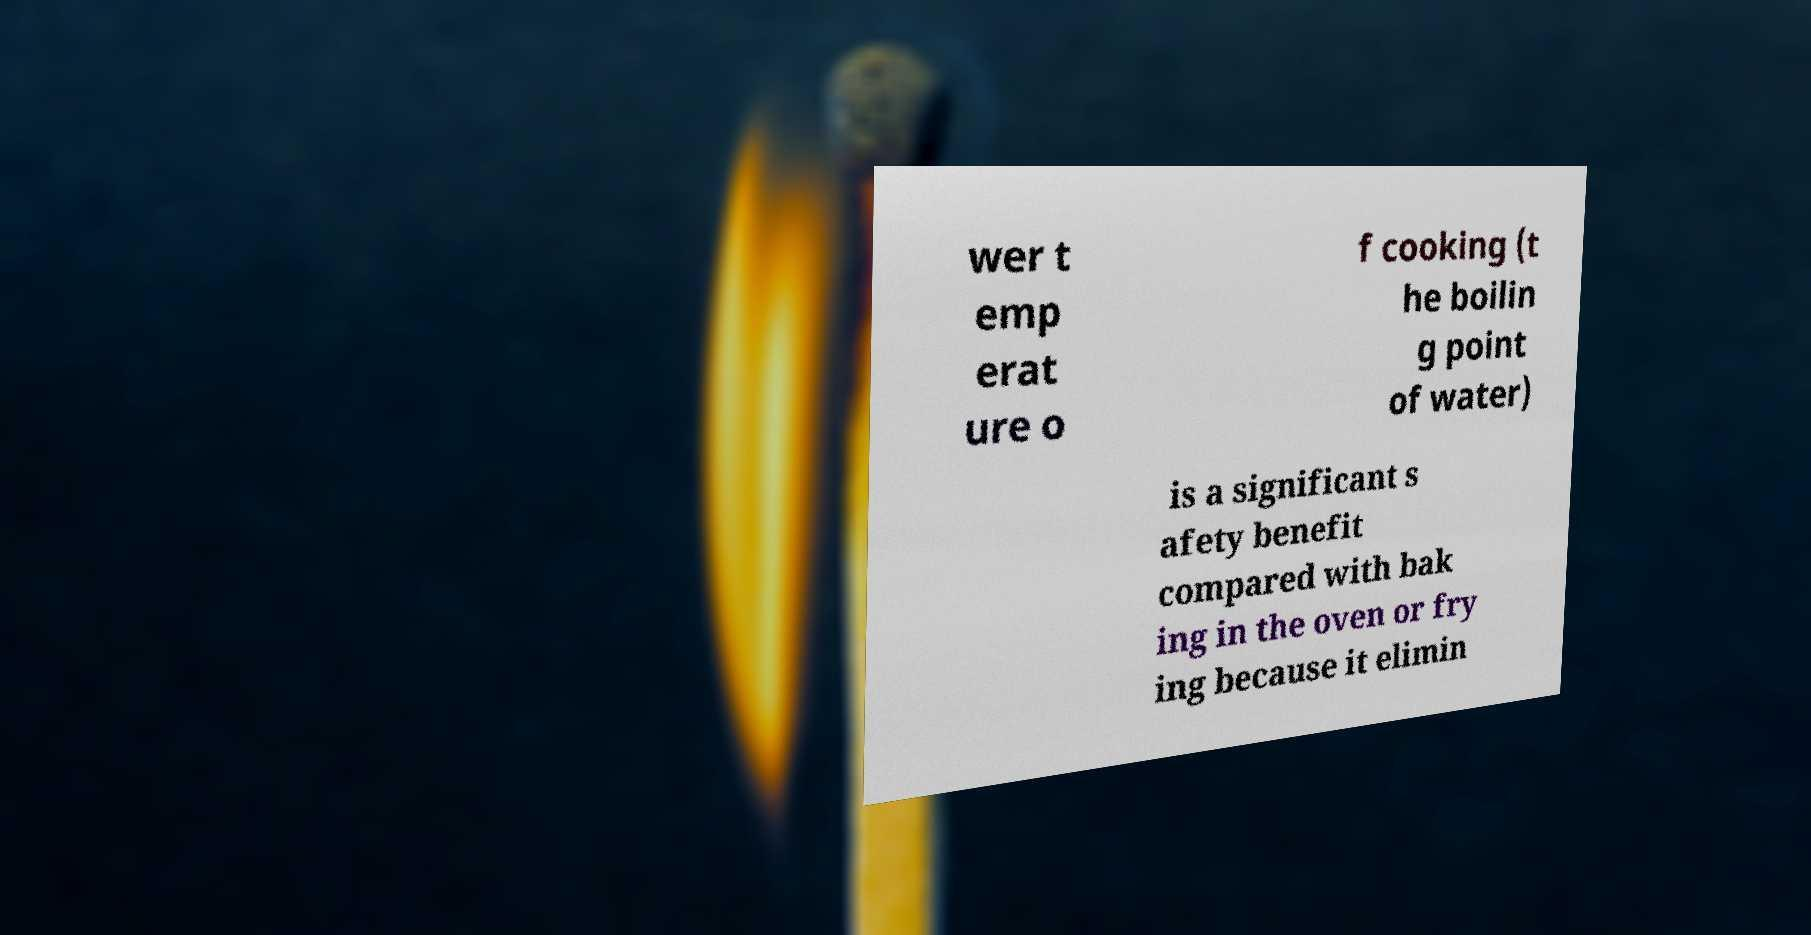I need the written content from this picture converted into text. Can you do that? wer t emp erat ure o f cooking (t he boilin g point of water) is a significant s afety benefit compared with bak ing in the oven or fry ing because it elimin 